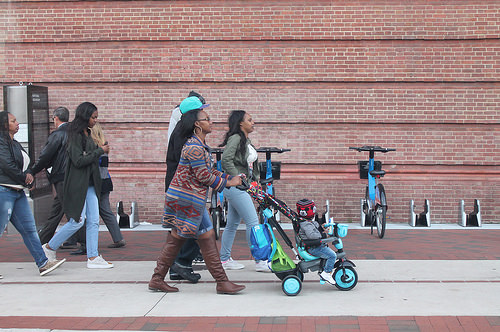<image>
Is there a child on the floor? No. The child is not positioned on the floor. They may be near each other, but the child is not supported by or resting on top of the floor. Is the woman behind the bag? Yes. From this viewpoint, the woman is positioned behind the bag, with the bag partially or fully occluding the woman. Is the baby in front of the woman? Yes. The baby is positioned in front of the woman, appearing closer to the camera viewpoint. 